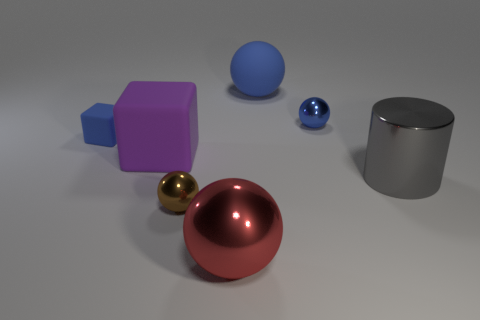What number of small metal spheres are the same color as the small rubber object?
Offer a terse response. 1. What material is the small cube that is the same color as the rubber ball?
Keep it short and to the point. Rubber. Is the color of the big matte sphere the same as the tiny matte object?
Give a very brief answer. Yes. Is there anything else that has the same shape as the gray metal thing?
Offer a terse response. No. There is a big matte thing that is to the left of the small sphere that is left of the matte object that is on the right side of the red thing; what color is it?
Your answer should be very brief. Purple. What number of things are either metal spheres behind the metal cylinder or large objects that are behind the big cylinder?
Your answer should be very brief. 3. How many other things are the same color as the large metallic cylinder?
Make the answer very short. 0. There is a small metal thing that is behind the large purple rubber thing; is it the same shape as the large blue matte thing?
Make the answer very short. Yes. Are there fewer tiny metal objects that are behind the red shiny object than tiny things?
Your answer should be compact. Yes. Is there a large red object that has the same material as the big gray cylinder?
Your response must be concise. Yes. 